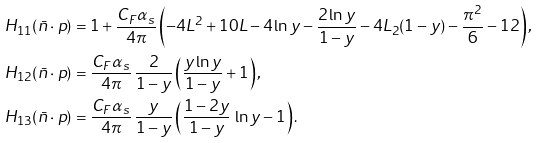Convert formula to latex. <formula><loc_0><loc_0><loc_500><loc_500>H _ { 1 1 } ( \bar { n } \cdot p ) & = 1 + \frac { C _ { F } \alpha _ { s } } { 4 \pi } \left ( - 4 L ^ { 2 } + 1 0 L - 4 \ln y - \frac { 2 \ln y } { 1 - y } - 4 L _ { 2 } ( 1 - y ) - \frac { \pi ^ { 2 } } { 6 } - 1 2 \right ) , \\ H _ { 1 2 } ( \bar { n } \cdot p ) & = \frac { C _ { F } \alpha _ { s } } { 4 \pi } \, \frac { 2 } { 1 - y } \left ( \frac { y \ln y } { 1 - y } + 1 \right ) , \\ H _ { 1 3 } ( \bar { n } \cdot p ) & = \frac { C _ { F } \alpha _ { s } } { 4 \pi } \, \frac { y } { 1 - y } \left ( \frac { 1 - 2 y } { 1 - y } \, \ln y - 1 \right ) .</formula> 